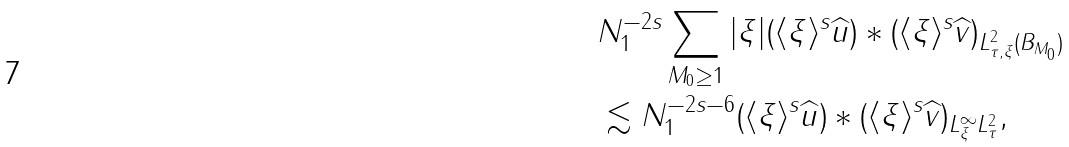<formula> <loc_0><loc_0><loc_500><loc_500>& N _ { 1 } ^ { - 2 s } \sum _ { M _ { 0 } \geq 1 } \| | \xi | ( \langle \xi \rangle ^ { s } \widehat { u } ) * ( \langle \xi \rangle ^ { s } \widehat { v } ) \| _ { L _ { \tau , \xi } ^ { 2 } ( B _ { M _ { 0 } } ) } \\ & \lesssim N _ { 1 } ^ { - 2 s - 6 } \| ( \langle \xi \rangle ^ { s } \widehat { u } ) * ( \langle \xi \rangle ^ { s } \widehat { v } ) \| _ { L _ { \xi } ^ { \infty } L _ { \tau } ^ { 2 } } ,</formula> 